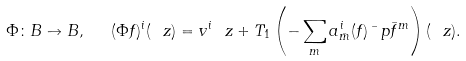Convert formula to latex. <formula><loc_0><loc_0><loc_500><loc_500>\Phi \colon B \to B , \ \ ( \Phi f ) ^ { i } ( \ z ) = v ^ { i } \ z + T _ { 1 } \left ( - \sum _ { m } a ^ { i } _ { \bar { m } } ( f ) \bar { \ } p { \bar { f } } ^ { m } \right ) ( \ z ) .</formula> 